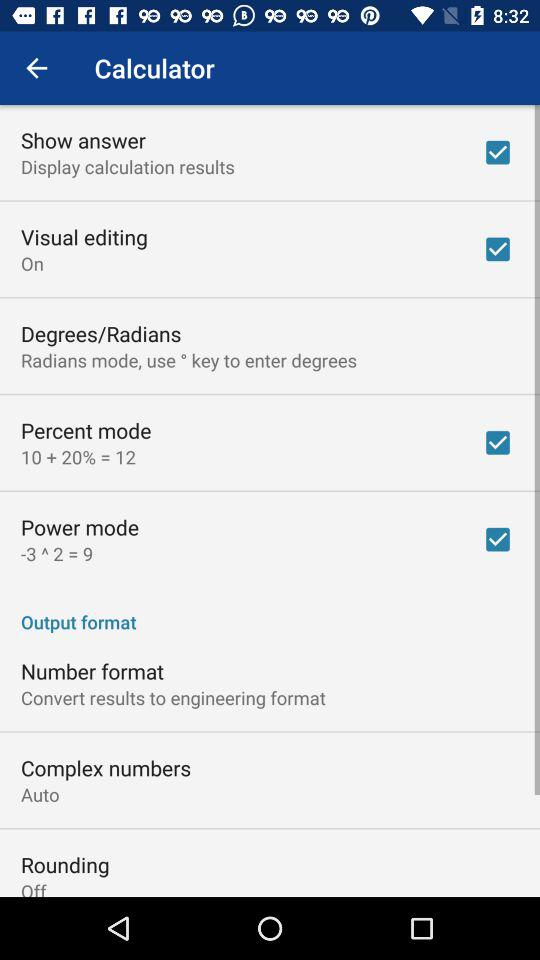What is the status of "Rounding"? The status is "off". 